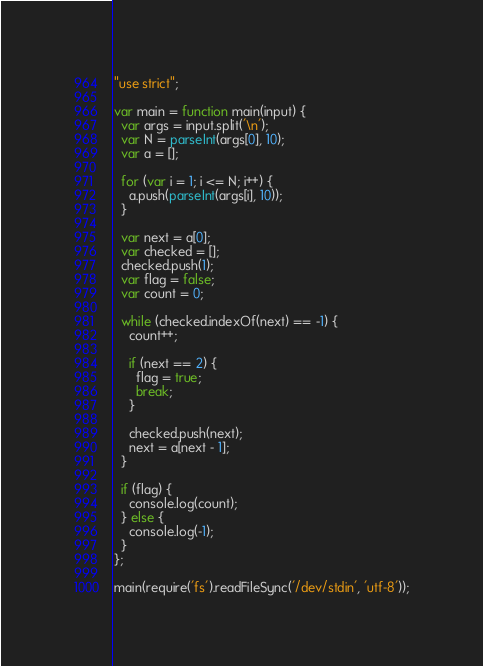<code> <loc_0><loc_0><loc_500><loc_500><_JavaScript_>"use strict";

var main = function main(input) {
  var args = input.split('\n');
  var N = parseInt(args[0], 10);
  var a = [];

  for (var i = 1; i <= N; i++) {
    a.push(parseInt(args[i], 10));
  }

  var next = a[0];
  var checked = [];
  checked.push(1);
  var flag = false;
  var count = 0;

  while (checked.indexOf(next) == -1) {
    count++;

    if (next == 2) {
      flag = true;
      break;
    }

    checked.push(next);
    next = a[next - 1];
  }

  if (flag) {
    console.log(count);
  } else {
    console.log(-1);
  }
};

main(require('fs').readFileSync('/dev/stdin', 'utf-8'));</code> 